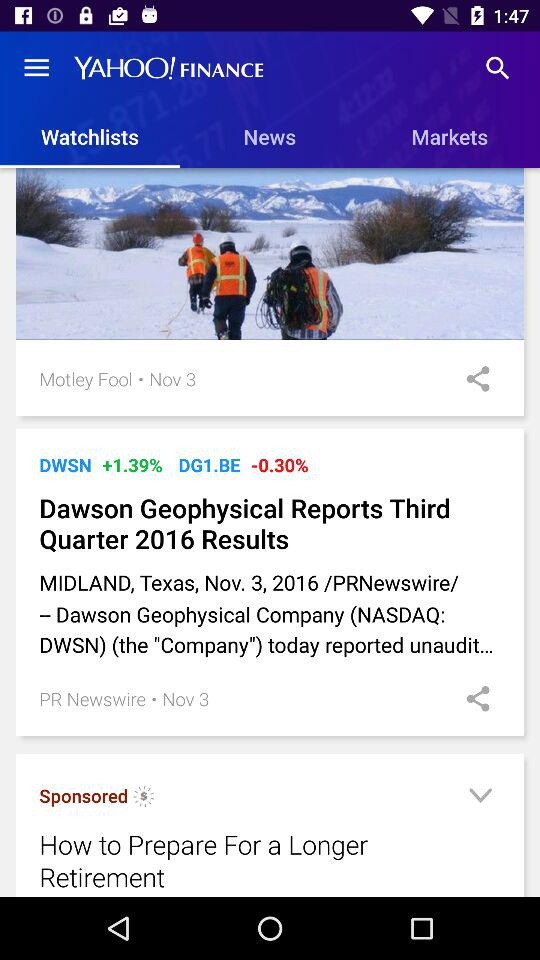What is the name of the application? The name of the application is "YAHOO! FINANCE". 